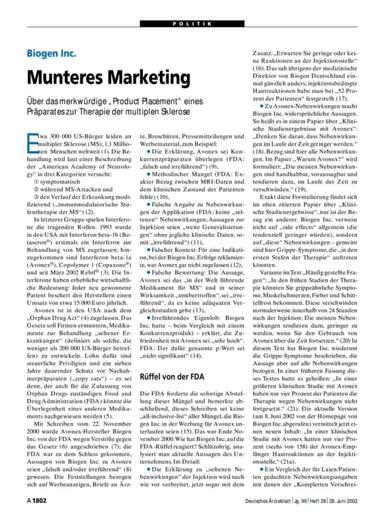How does the FDA's involvement appear in regard to Biogen Inc.'s product? The FDA has issued warnings to Biogen Inc., as mentioned, indicating a regulatory challenge and emphasizing the importance of compliance in marketing practices. This points to a critical oversight role played by the FDA in ensuring that marketing claims are substantiated and ethical. 